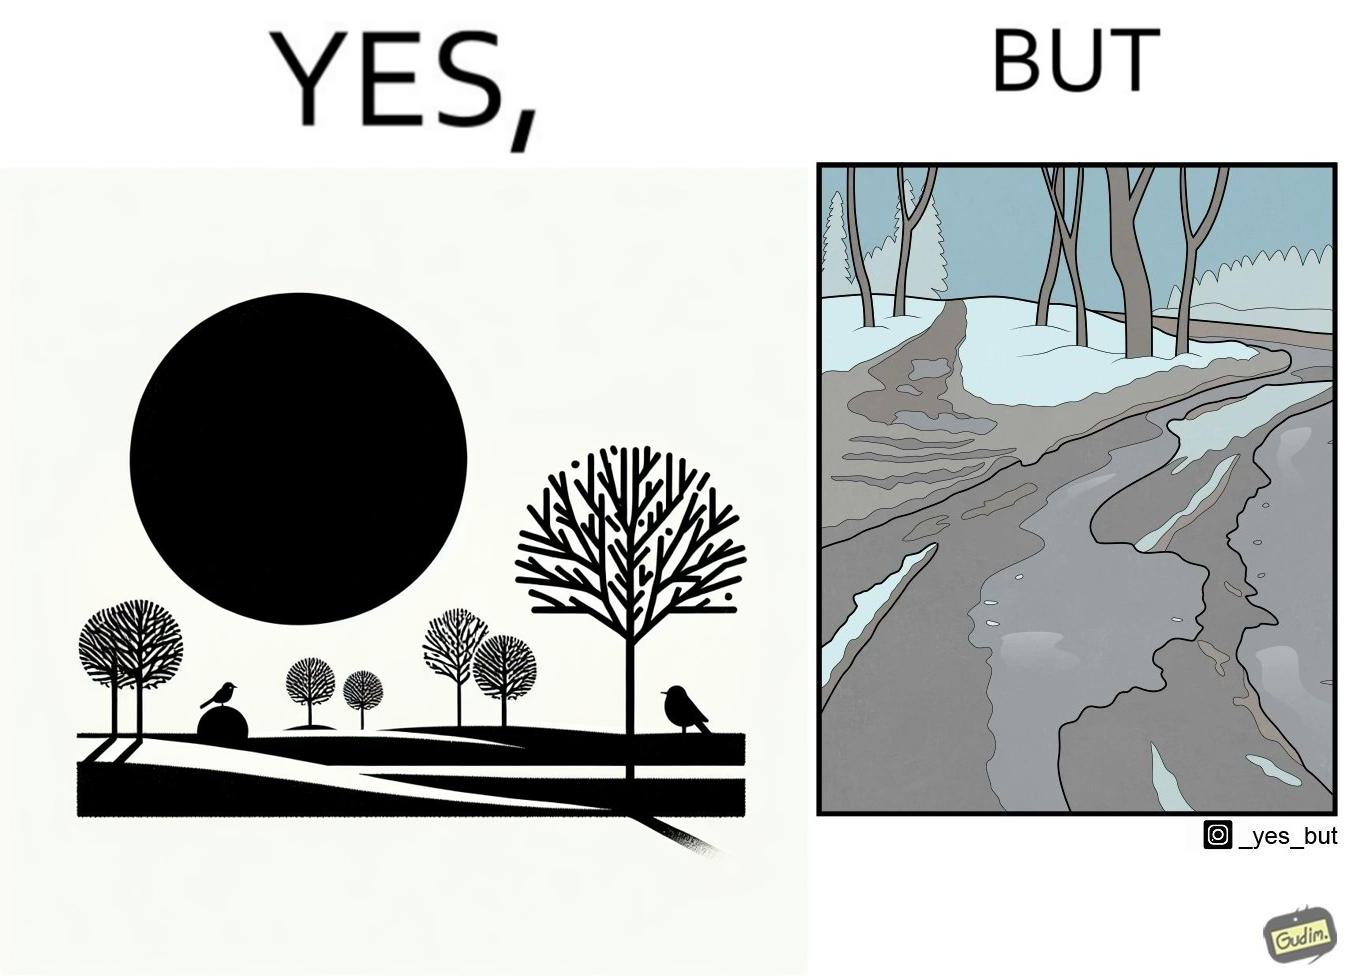What does this image depict? The image is funny, as from far, snow covered mountains look really scenic and completely white, but when zooming in near trees, the ground is partially covered in snow, and is not as scenic anymore. 